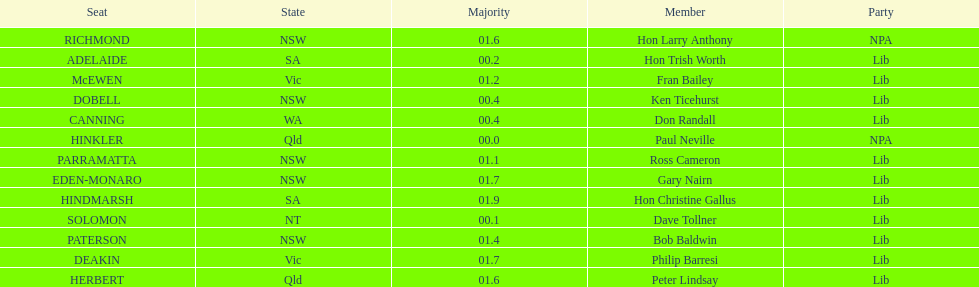Who is listed before don randall? Hon Trish Worth. 